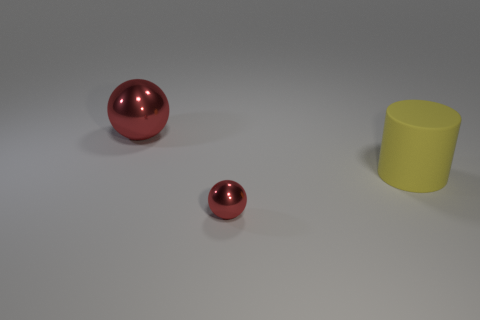Add 1 big rubber things. How many objects exist? 4 Subtract all cylinders. How many objects are left? 2 Add 3 tiny brown blocks. How many tiny brown blocks exist? 3 Subtract 0 green balls. How many objects are left? 3 Subtract all yellow objects. Subtract all large objects. How many objects are left? 0 Add 2 tiny red things. How many tiny red things are left? 3 